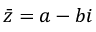Convert formula to latex. <formula><loc_0><loc_0><loc_500><loc_500>{ \bar { z } } = a - b i</formula> 